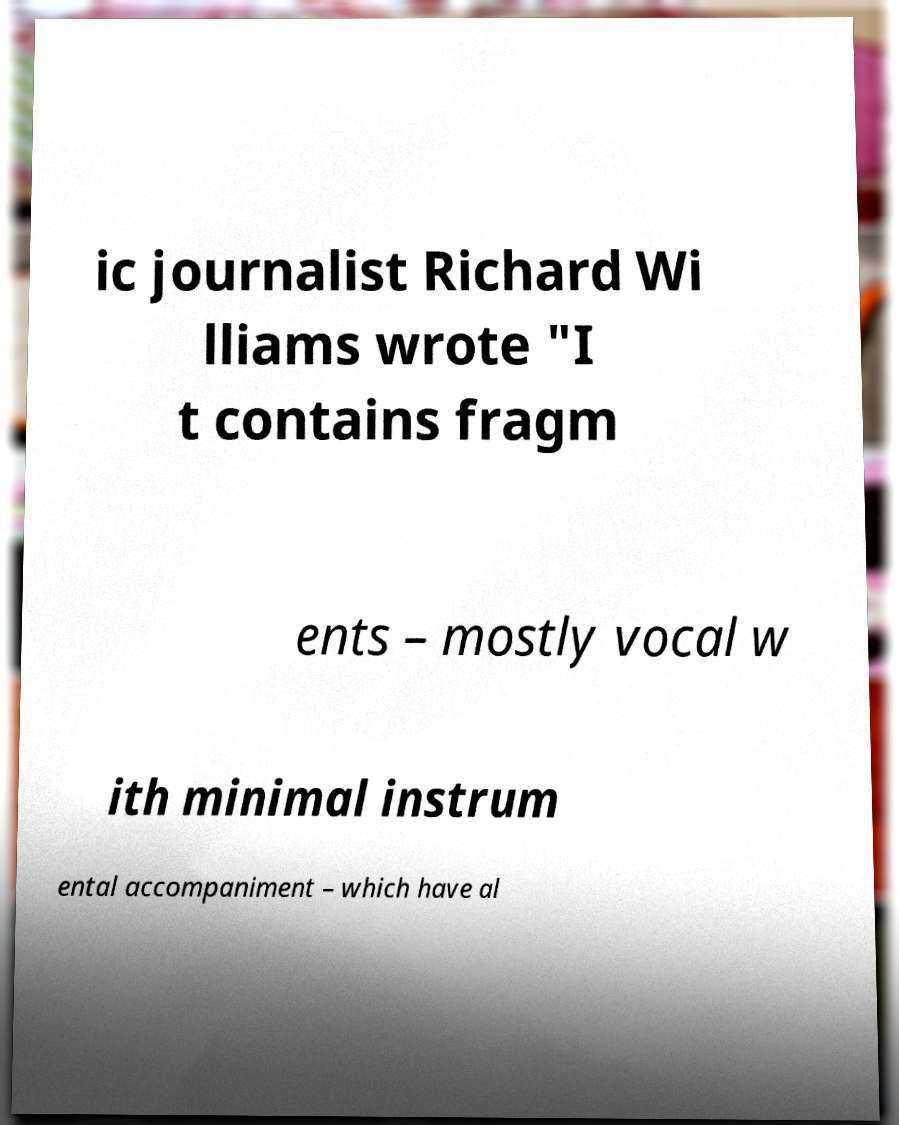Can you read and provide the text displayed in the image?This photo seems to have some interesting text. Can you extract and type it out for me? ic journalist Richard Wi lliams wrote "I t contains fragm ents – mostly vocal w ith minimal instrum ental accompaniment – which have al 